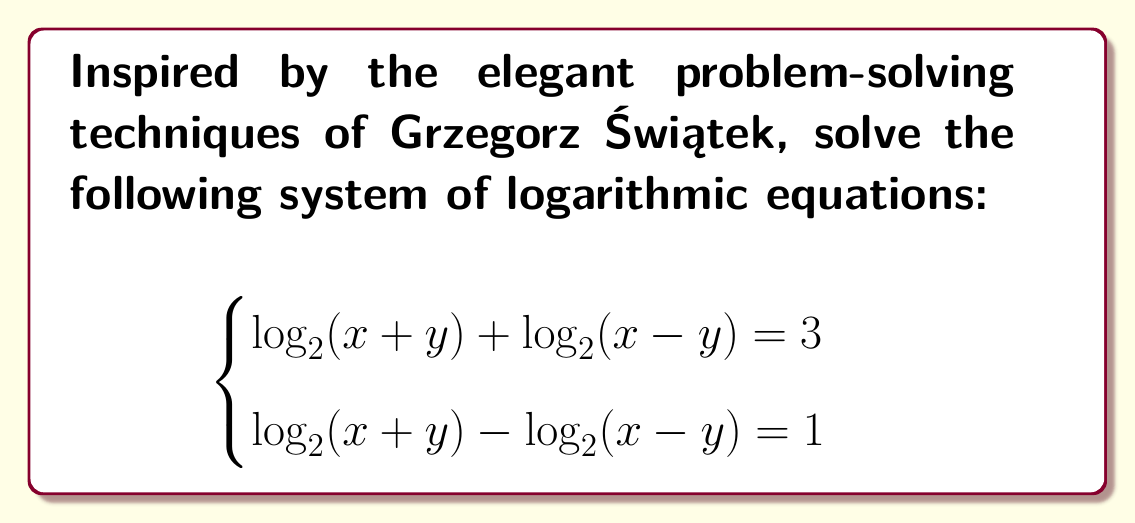Can you answer this question? Let's approach this step-by-step, using techniques that would make Grzegorz Świątek proud:

1) Let $a = \log_2(x+y)$ and $b = \log_2(x-y)$. Our system becomes:

   $$\begin{cases}
   a + b = 3 \\
   a - b = 1
   \end{cases}$$

2) Adding these equations:

   $(a + b) + (a - b) = 3 + 1$
   $2a = 4$
   $a = 2$

3) Subtracting the second equation from the first:

   $(a + b) - (a - b) = 3 - 1$
   $2b = 2$
   $b = 1$

4) Now we know that:

   $\log_2(x+y) = 2$ and $\log_2(x-y) = 1$

5) Let's solve these:

   $x + y = 2^2 = 4$
   $x - y = 2^1 = 2$

6) Adding these equations:

   $(x + y) + (x - y) = 4 + 2$
   $2x = 6$
   $x = 3$

7) Subtracting the second equation from the first:

   $(x + y) - (x - y) = 4 - 2$
   $2y = 2$
   $y = 1$

8) Verify:

   $\log_2(3+1) + \log_2(3-1) = \log_2(4) + \log_2(2) = 2 + 1 = 3$
   $\log_2(3+1) - \log_2(3-1) = \log_2(4) - \log_2(2) = 2 - 1 = 1$
Answer: $x = 3, y = 1$ 